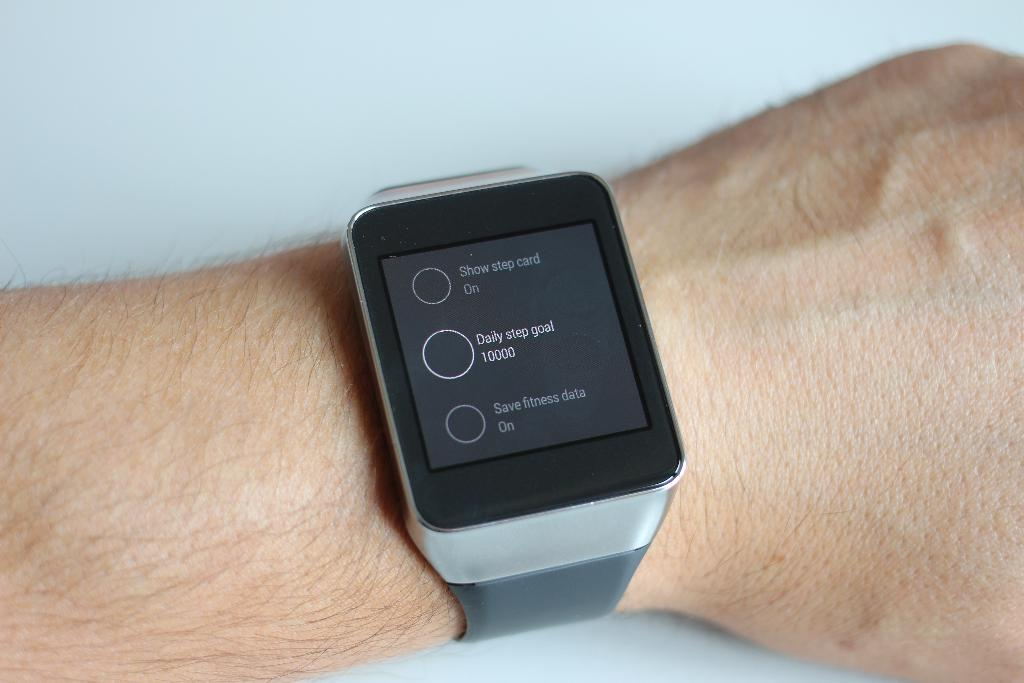<image>
Present a compact description of the photo's key features. A wrist is shown with a smart watch that displays a daily step goal of 10,000 steps. 